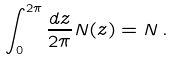<formula> <loc_0><loc_0><loc_500><loc_500>\int _ { 0 } ^ { 2 \pi } \frac { d z } { 2 \pi } N ( z ) = N \, .</formula> 